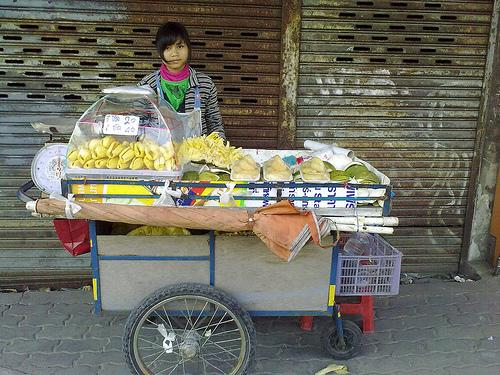Discuss the type of umbrella present in the image and its purpose. There is a closed parasol on the side of the cart, which might be used to shelter the vendor or her customers from sun or rain. Investigate and evaluate the overall image sentiment. The image sentiment is generally neutral, depicting an everyday street scene with a food cart vendor selling her products. Analyze the graffiti present in the image and specify its location. There is graffiti on the building located behind the cart, featuring white markings and a row of holes on the metal wall. Identify the sizes, colors, and functions of the basket and bag on the cart. The basket is blue, measuring 85 by 85 pixels, and may hold items for sale or storage. The bag is red, sized 42 by 42 pixels, and might be for customer purchases or vendor supplies. Identify the occupation of the woman in the image. The woman is a street food vendor, selling food from her cart. What objects can be found on top of the food cart? A white price tag, a scale, a roll of paper towel, food in plastic containers, some bananas under a dome, and covered food. Analyze the interaction between objects on the cart and their role in the vendor's business. The umbrella provides shelter, the scale is for weighing products, the price tag informs customers, the basket and bag might hold supplies or purchases, and the food on the cart attracts potential buyers. Count the number of wheels on the food cart and describe their size. The food cart has two wheels; one is big, and the other is small. In what ways are fabrics used in the woman's outfit? The woman has a green scarf, is wearing a striped shirt, and has pink fabric around her neck. What type of food does it seem like the woman is selling on her cart? It seems like the woman is selling various types of street food, including some yellow food in a plastic container and bananas. What is the state of the food on the cart in terms of exposure? The food is covered with a cover or plastic container. Is there any litter on the sidewalk in the image? Yes, there is trash laying on the side walk. How many wheels are visible on the food cart? Two wheels are visible on the food cart. Identify the position of the white pole on the side of the food cart. White pole coordinates: X:322 Y:206 Width:80 Height:80 Describe the interaction between the woman and the cart. The woman is standing behind the cart, likely operating it to sell food to customers. Is there any graffiti on the walls behind the cart? Yes, there is graffiti on the walls behind the cart. What type of clothing is the woman wearing? The woman is wearing a striped shirt. Describe the appearance of the cart and its surrounding area. The cart is blue and small. It's surrounded by a graffiti-covered wall, a red stool with a basket, and grey stones on the path. Locate the closed umbrella in the image. Closed umbrella coordinates: X:23 Y:196 Width:375 Height:375 Identify the color of the woman's scarf. The woman's scarf is green. What is written on the white price tag? The text on the white price tag is not discernible from the image. Which objects on the cart indicate that it's a mobile food cart? The wheels, the umbrella, and various food items displayed on the cart indicate that it's a mobile food cart. Describe the quality of the image. The image is of moderate quality with clear object visibility and distinguishable features. What emotions are expressed in the image? The image's sentiment is neutral, as there are no strong emotions expressed. Describe the scene in the image. A woman is standing by a food cart, selling food under an umbrella. There are various items on the cart, like a scale, a price tag, and a basket. The surroundings have graffiti on the wall and some trash on the side walk. Is the umbrella open or closed? The umbrella is closed. List the types of food displayed on the cart. Food in a plastic container, bananas under a dome, food covered with a cover. What is the purpose of the wall behind the cart? The wall may be a building's exterior which has graffiti on it. Choose the most accurate and complete description of the scale on the cart. (a) white and small, (b) blue and small, (c) white and large, (d) blue and large. a) white and small. What color is the basket on the cart? The basket on the cart is purple. 